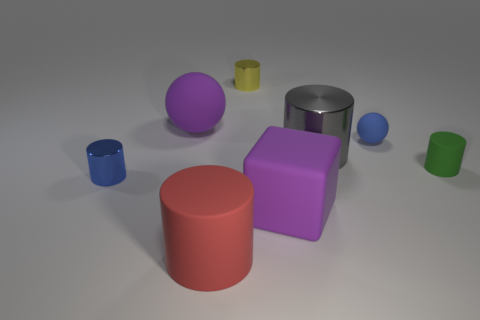Add 2 small yellow shiny cylinders. How many objects exist? 10 Subtract all balls. How many objects are left? 6 Subtract all green cylinders. How many gray spheres are left? 0 Subtract all red shiny blocks. Subtract all small yellow cylinders. How many objects are left? 7 Add 8 tiny blue rubber spheres. How many tiny blue rubber spheres are left? 9 Add 4 small shiny cylinders. How many small shiny cylinders exist? 6 Subtract all yellow cylinders. How many cylinders are left? 4 Subtract all big matte cylinders. How many cylinders are left? 4 Subtract 0 cyan balls. How many objects are left? 8 Subtract 1 spheres. How many spheres are left? 1 